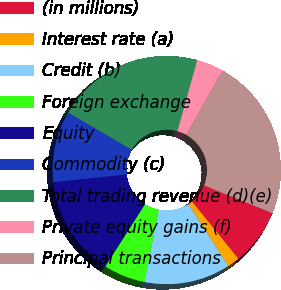Convert chart. <chart><loc_0><loc_0><loc_500><loc_500><pie_chart><fcel>(in millions)<fcel>Interest rate (a)<fcel>Credit (b)<fcel>Foreign exchange<fcel>Equity<fcel>Commodity (c)<fcel>Total trading revenue (d)(e)<fcel>Private equity gains (f)<fcel>Principal transactions<nl><fcel>8.02%<fcel>1.74%<fcel>12.21%<fcel>5.92%<fcel>14.3%<fcel>10.11%<fcel>20.89%<fcel>3.83%<fcel>22.98%<nl></chart> 